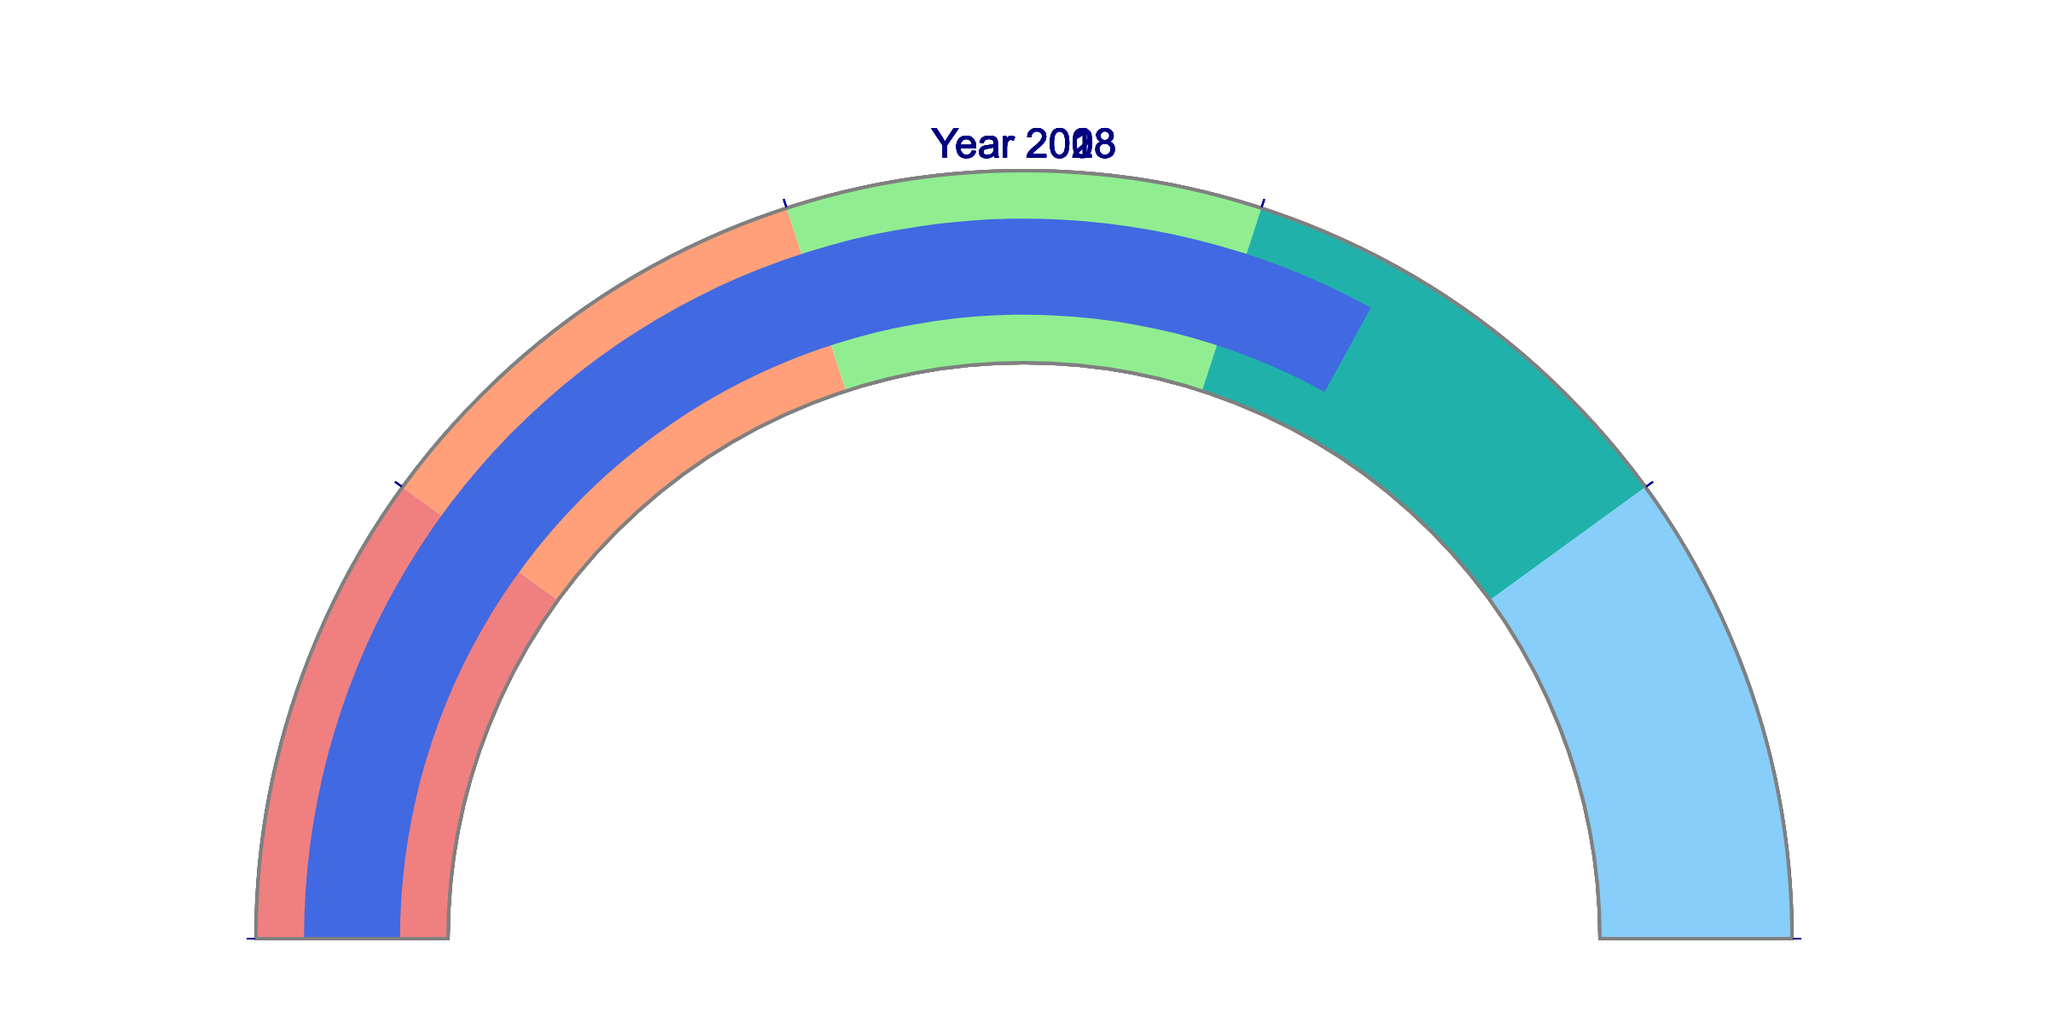What's the title of the figure? The title is displayed at the top center of the figure. It is written in white and large font size.
Answer: Overall Public Trust in Mainstream Media How many years are shown in the figure? There are five gauges, each representing a different year.
Answer: 5 What is the trust percentage in mainstream media for the year 2023? The gauge for the year 2023 shows a number inside it representing the trust percentage.
Answer: 42 Between which years did the trust percentage decrease the most? By comparing the values from each year, the biggest drop is observed between 2013 (54) and 2018 (48).
Answer: Between 2013 and 2018 What was the trust percentage in 2003 and how does it compare to 2023? In 2003, it was 66%; in 2023, it is 42%. This shows a decrease over the years.
Answer: 66 in 2003, decreased by 24 to 42 in 2023 What is the difference in trust percentage between 2008 and 2023? The gauge for 2008 shows 60, and the one for 2023 shows 42. Subtracting these values gives the difference.
Answer: 18 Which year has the highest trust percentage? Among all the values shown in the gauges, the highest one is for the year 2003.
Answer: 2003 What is the average trust percentage across all years? The sum of the percentages (42, 48, 54, 60, 66) is 270. Dividing by 5 gives the average.
Answer: 54 How does the trust percentage in 2018 compare to 2013? The gauge for 2018 shows 48, and for 2013 it shows 54, so there is a decrease.
Answer: Decreased from 54 to 48 What are the color ranges used in the gauges? The gauges use five color ranges: lightcoral (0-20), lightsalmon (20-40), lightgreen (40-60), lightseagreen (60-80), lightskyblue (80-100).
Answer: lightcoral, lightsalmon, lightgreen, lightseagreen, lightskyblue 